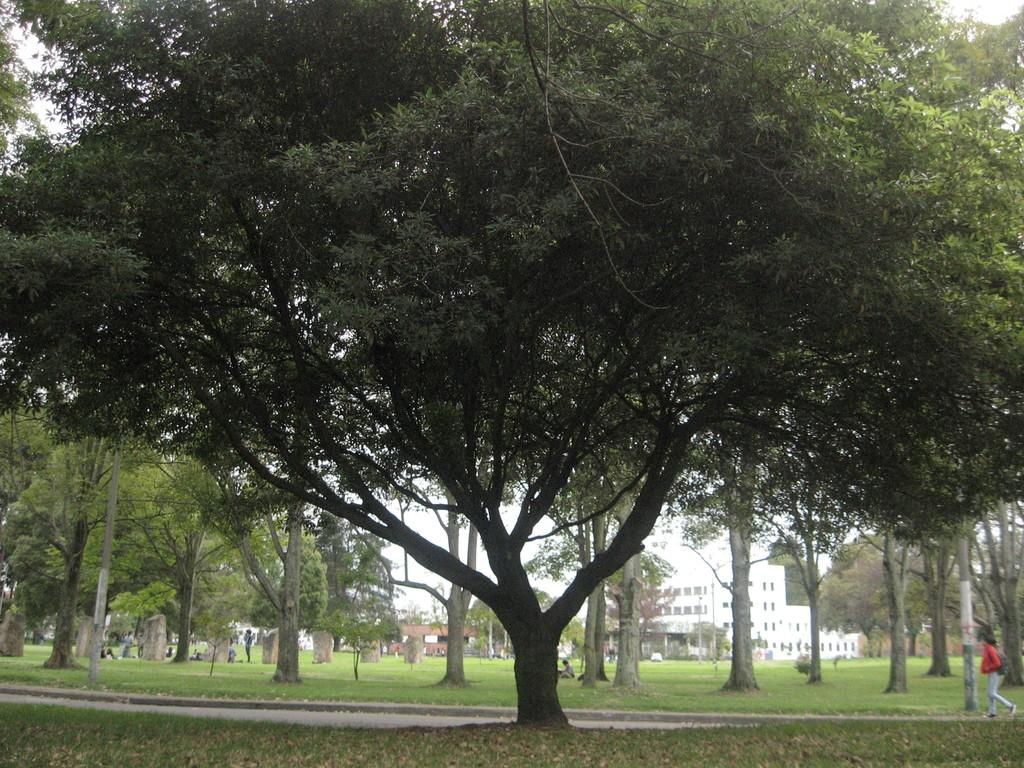What is the person in the image doing? The person is walking at the right side of the image. Where is the person walking? The person is walking on a walkway. What type of vegetation can be seen in the image? There is grass and trees in the image. What structures are present in the image? There are poles and a building in the image. What is the condition of the sky in the image? The sky is clear in the image. What type of unit is being measured by the person walking in the image? There is no indication in the image that the person is measuring any units. What part of the brain can be seen in the image? There is no brain visible in the image. 